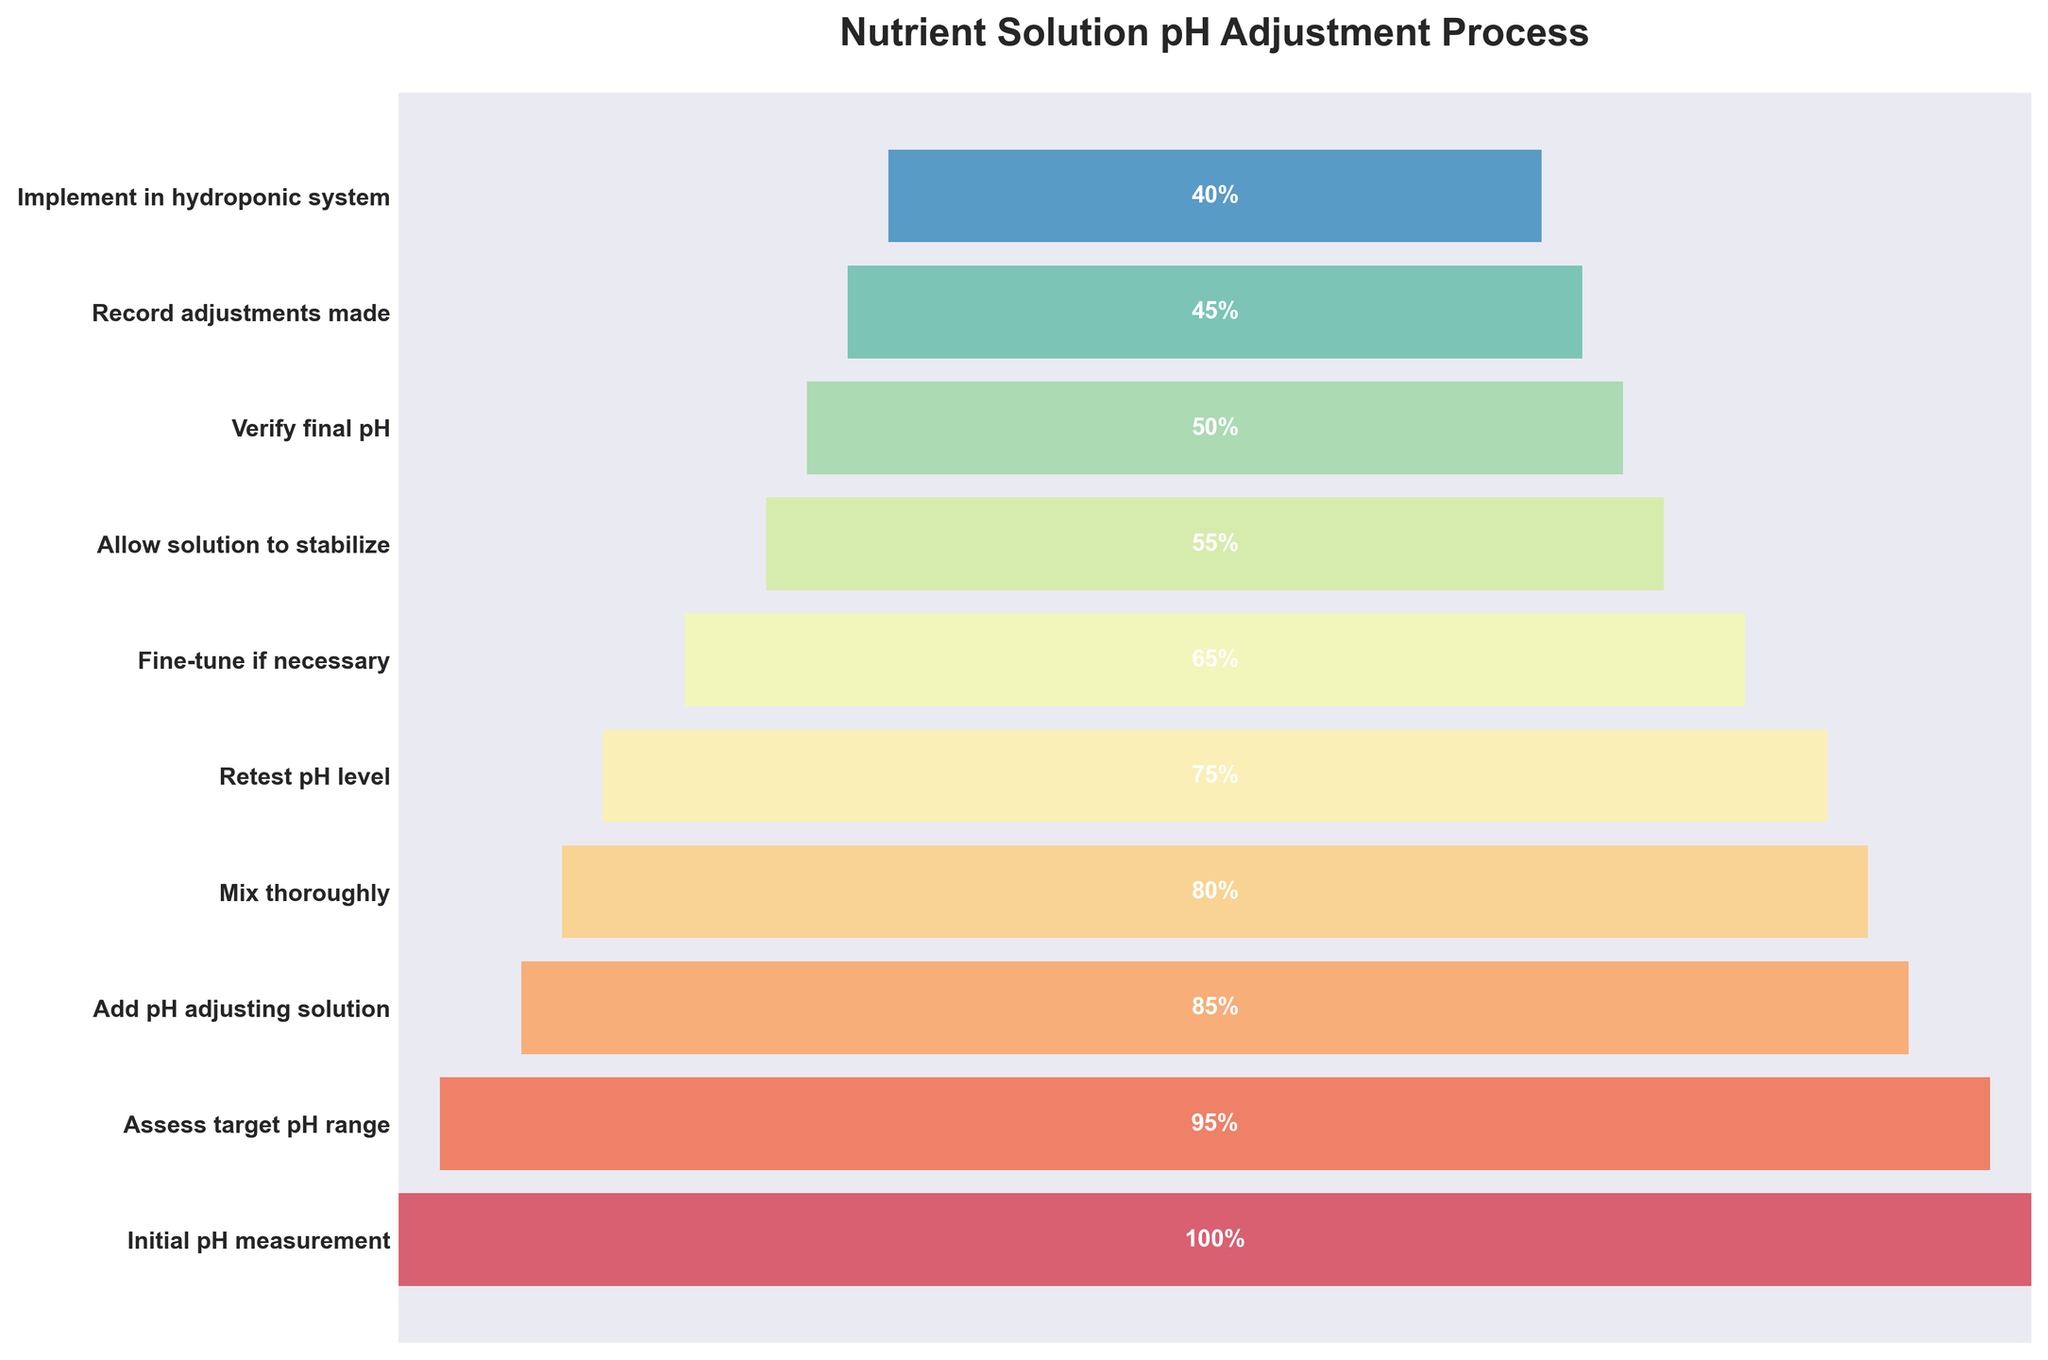What is the title of the plot? The title of the plot is written at the top and summarizes the main focus of the visual representation.
Answer: Nutrient Solution pH Adjustment Process How many stages are depicted in the plot? Count the distinct stages labeled along the y-axis of the funnel chart.
Answer: 10 Which stage has the highest percentage value? The highest percentage value is displayed at the top of the funnel and represents the initial stage.
Answer: Initial pH measurement What's the percentage difference between "Add pH adjusting solution" and "Fine-tune if necessary"? Subtract the percentage of "Fine-tune if necessary" (65%) from "Add pH adjusting solution" (85%).
Answer: 20% How much does the percentage decrease from "Initial pH measurement" to "Verify final pH"? Subtract the percentage of "Verify final pH" (50%) from "Initial pH measurement" (100%).
Answer: 50% Is the percentage of "Implement in hydroponic system" greater than or equal to the percentage of "Allow solution to stabilize"? Compare the percentage values of "Implement in hydroponic system" (40%) and "Allow solution to stabilize" (55%).
Answer: No Which stages have a percentage value less than or equal to 50%? Check stages with percentages less than or equal to 50%: "Verify final pH" (50%), "Record adjustments made" (45%), and "Implement in hydroponic system" (40%).
Answer: Verify final pH, Record adjustments made, Implement in hydroponic system What is the total percentage summed for "Mix thoroughly" and "Retest pH level"? Add the percentage values for "Mix thoroughly" (80%) and "Retest pH level" (75%).
Answer: 155% What color scheme is used for the plot? Identify the color scheme applied to the bars in the funnel chart. The color scheme in the funnel chart gradually transitions using the Spectral colormap.
Answer: Spectral colormap What stage directly follows "Mix thoroughly" and what is its percentage? Identify the stage immediately after "Mix thoroughly" and look at its percentage value.
Answer: Retest pH level, 75% 